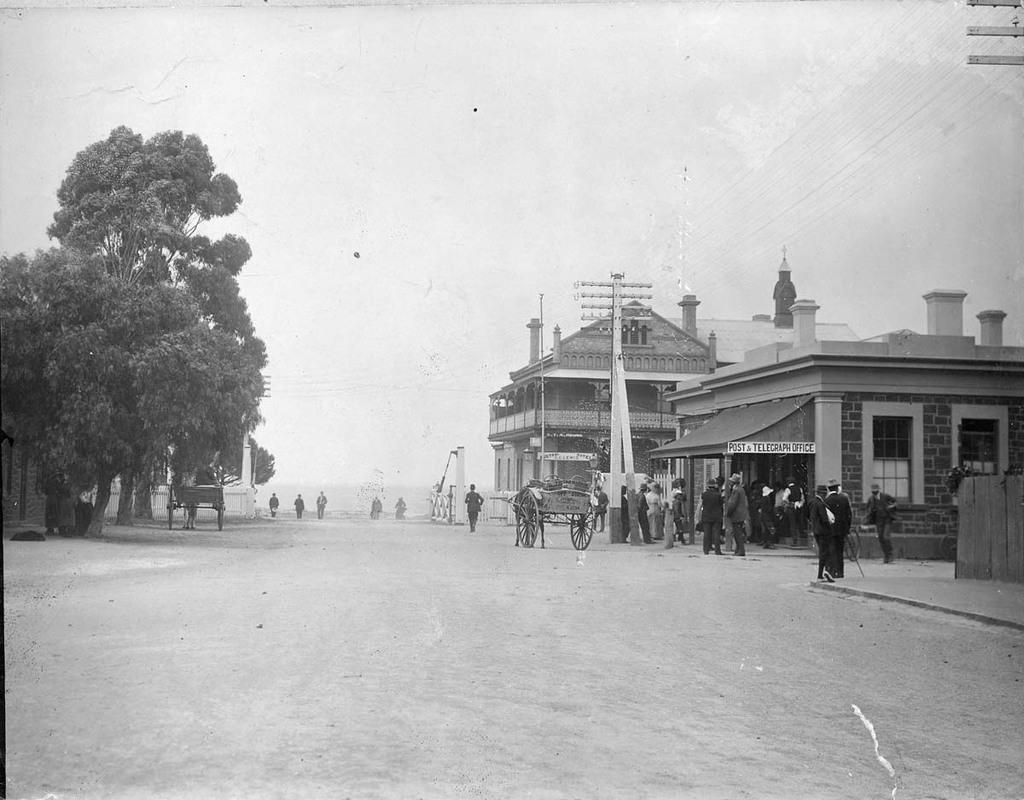What types of living organisms can be seen in the image? People and animals are visible in the image. What structures are present in the image? There are houses, electric poles, and a fence in the image. What type of transportation can be seen in the image? Vehicles are visible in the image. What natural elements are present in the image? Trees and land are visible in the image. What is visible in the sky in the image? The sky is visible in the image. What operation is the uncle performing on the animals in the image? There is no uncle present in the image, and no operation is being performed on the animals. 